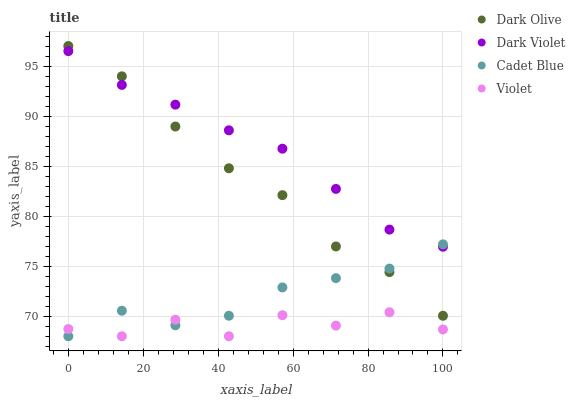Does Violet have the minimum area under the curve?
Answer yes or no. Yes. Does Dark Violet have the maximum area under the curve?
Answer yes or no. Yes. Does Dark Olive have the minimum area under the curve?
Answer yes or no. No. Does Dark Olive have the maximum area under the curve?
Answer yes or no. No. Is Dark Violet the smoothest?
Answer yes or no. Yes. Is Violet the roughest?
Answer yes or no. Yes. Is Dark Olive the smoothest?
Answer yes or no. No. Is Dark Olive the roughest?
Answer yes or no. No. Does Cadet Blue have the lowest value?
Answer yes or no. Yes. Does Dark Olive have the lowest value?
Answer yes or no. No. Does Dark Olive have the highest value?
Answer yes or no. Yes. Does Dark Violet have the highest value?
Answer yes or no. No. Is Violet less than Dark Olive?
Answer yes or no. Yes. Is Dark Olive greater than Violet?
Answer yes or no. Yes. Does Dark Olive intersect Dark Violet?
Answer yes or no. Yes. Is Dark Olive less than Dark Violet?
Answer yes or no. No. Is Dark Olive greater than Dark Violet?
Answer yes or no. No. Does Violet intersect Dark Olive?
Answer yes or no. No. 